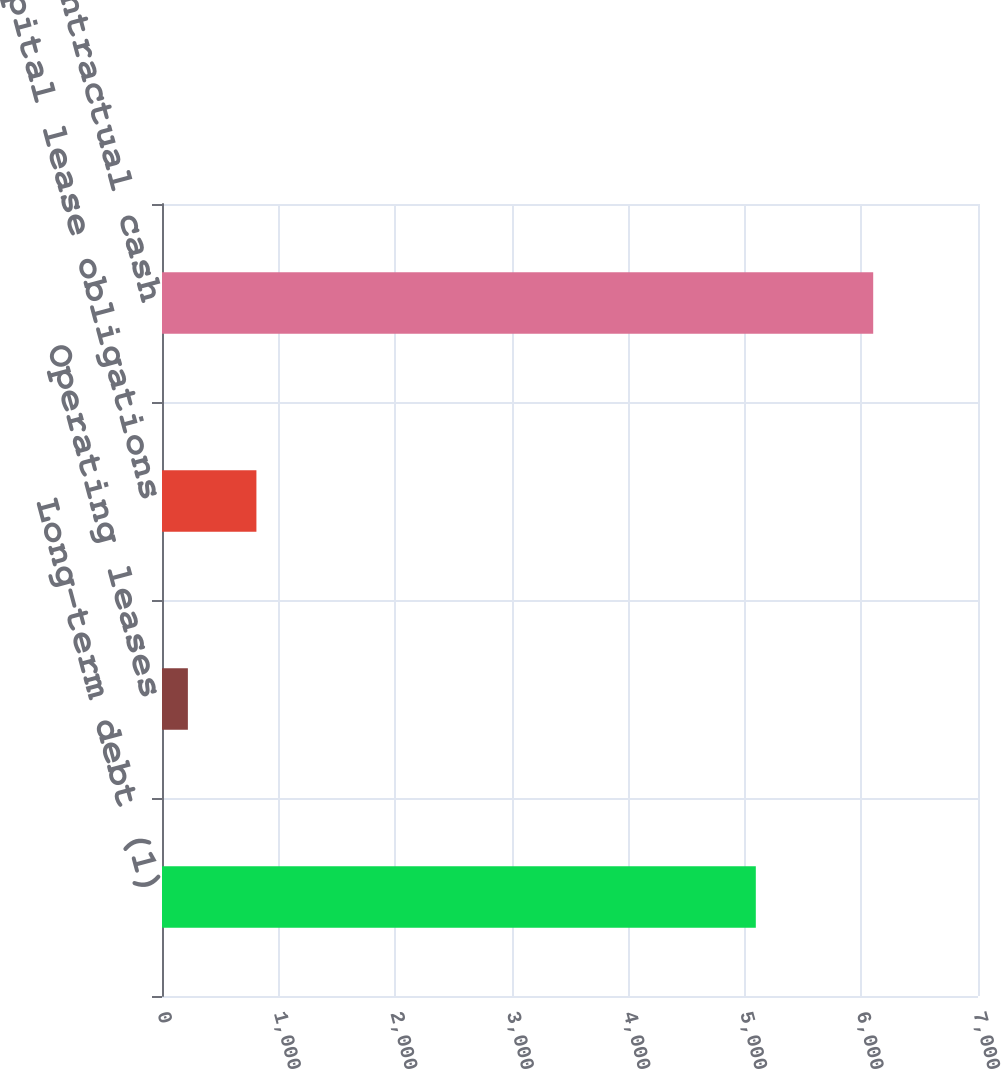Convert chart to OTSL. <chart><loc_0><loc_0><loc_500><loc_500><bar_chart><fcel>Long-term debt (1)<fcel>Operating leases<fcel>Capital lease obligations<fcel>Total contractual cash<nl><fcel>5094<fcel>222<fcel>809.9<fcel>6101<nl></chart> 